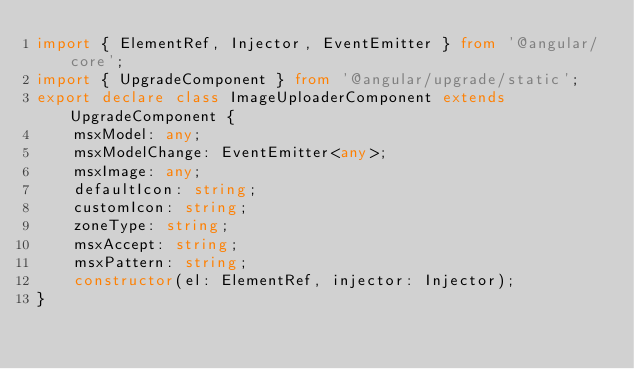<code> <loc_0><loc_0><loc_500><loc_500><_TypeScript_>import { ElementRef, Injector, EventEmitter } from '@angular/core';
import { UpgradeComponent } from '@angular/upgrade/static';
export declare class ImageUploaderComponent extends UpgradeComponent {
    msxModel: any;
    msxModelChange: EventEmitter<any>;
    msxImage: any;
    defaultIcon: string;
    customIcon: string;
    zoneType: string;
    msxAccept: string;
    msxPattern: string;
    constructor(el: ElementRef, injector: Injector);
}
</code> 